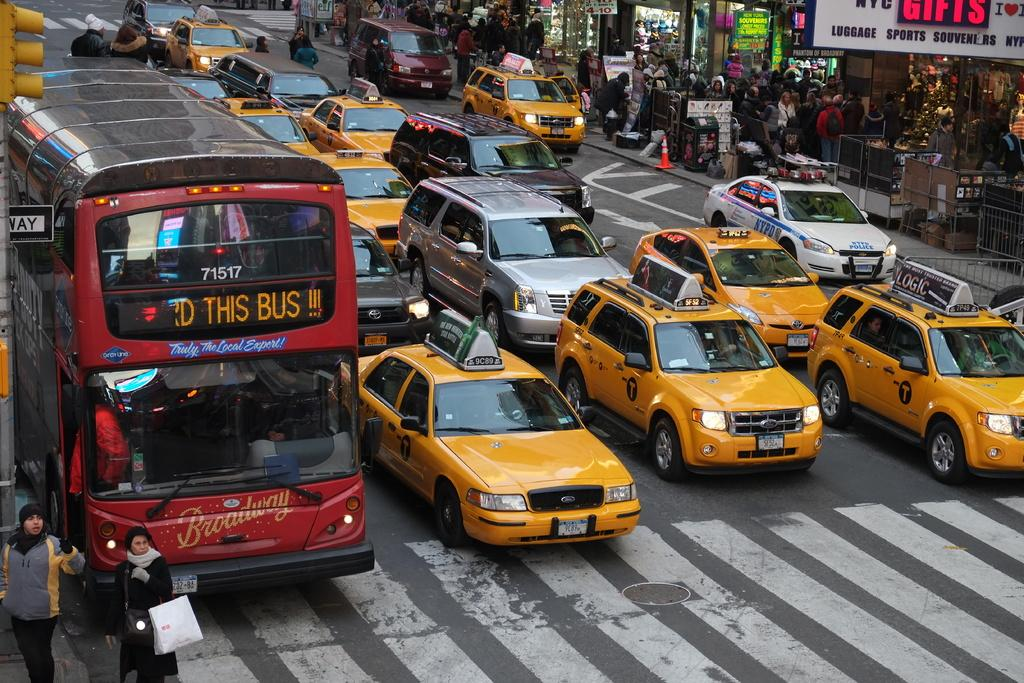<image>
Describe the image concisely. a large bus next to taxis with 71517 on it 